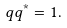Convert formula to latex. <formula><loc_0><loc_0><loc_500><loc_500>q q ^ { * } = 1 .</formula> 